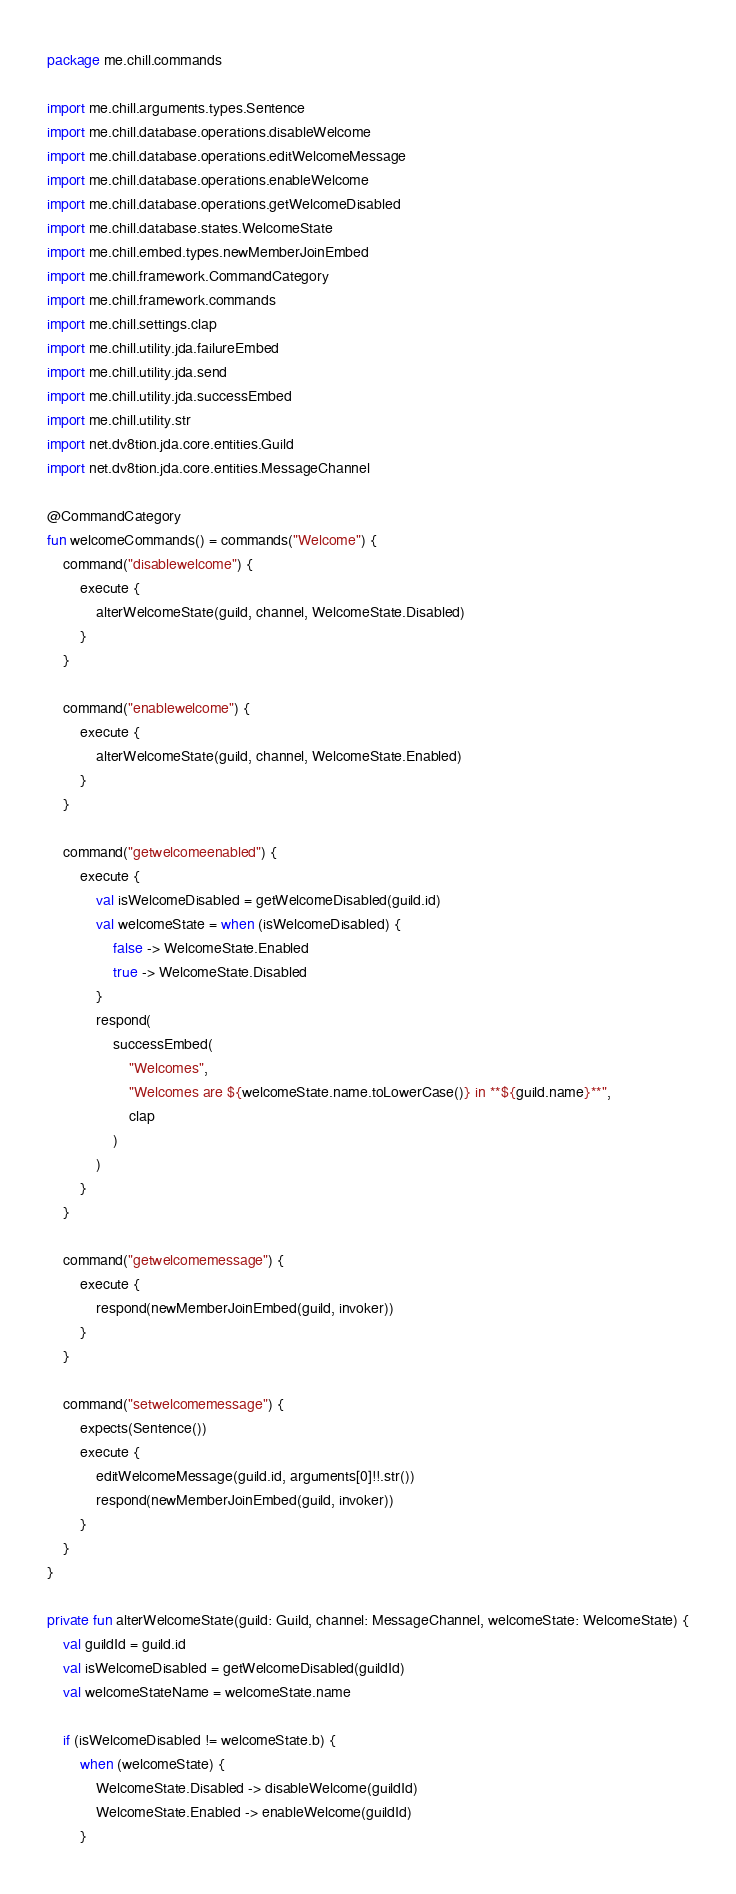Convert code to text. <code><loc_0><loc_0><loc_500><loc_500><_Kotlin_>package me.chill.commands

import me.chill.arguments.types.Sentence
import me.chill.database.operations.disableWelcome
import me.chill.database.operations.editWelcomeMessage
import me.chill.database.operations.enableWelcome
import me.chill.database.operations.getWelcomeDisabled
import me.chill.database.states.WelcomeState
import me.chill.embed.types.newMemberJoinEmbed
import me.chill.framework.CommandCategory
import me.chill.framework.commands
import me.chill.settings.clap
import me.chill.utility.jda.failureEmbed
import me.chill.utility.jda.send
import me.chill.utility.jda.successEmbed
import me.chill.utility.str
import net.dv8tion.jda.core.entities.Guild
import net.dv8tion.jda.core.entities.MessageChannel

@CommandCategory
fun welcomeCommands() = commands("Welcome") {
	command("disablewelcome") {
		execute {
			alterWelcomeState(guild, channel, WelcomeState.Disabled)
		}
	}

	command("enablewelcome") {
		execute {
			alterWelcomeState(guild, channel, WelcomeState.Enabled)
		}
	}

	command("getwelcomeenabled") {
		execute {
			val isWelcomeDisabled = getWelcomeDisabled(guild.id)
			val welcomeState = when (isWelcomeDisabled) {
				false -> WelcomeState.Enabled
				true -> WelcomeState.Disabled
			}
			respond(
				successEmbed(
					"Welcomes",
					"Welcomes are ${welcomeState.name.toLowerCase()} in **${guild.name}**",
					clap
				)
			)
		}
	}

	command("getwelcomemessage") {
		execute {
			respond(newMemberJoinEmbed(guild, invoker))
		}
	}

	command("setwelcomemessage") {
		expects(Sentence())
		execute {
			editWelcomeMessage(guild.id, arguments[0]!!.str())
			respond(newMemberJoinEmbed(guild, invoker))
		}
	}
}

private fun alterWelcomeState(guild: Guild, channel: MessageChannel, welcomeState: WelcomeState) {
	val guildId = guild.id
	val isWelcomeDisabled = getWelcomeDisabled(guildId)
	val welcomeStateName = welcomeState.name

	if (isWelcomeDisabled != welcomeState.b) {
		when (welcomeState) {
			WelcomeState.Disabled -> disableWelcome(guildId)
			WelcomeState.Enabled -> enableWelcome(guildId)
		}</code> 